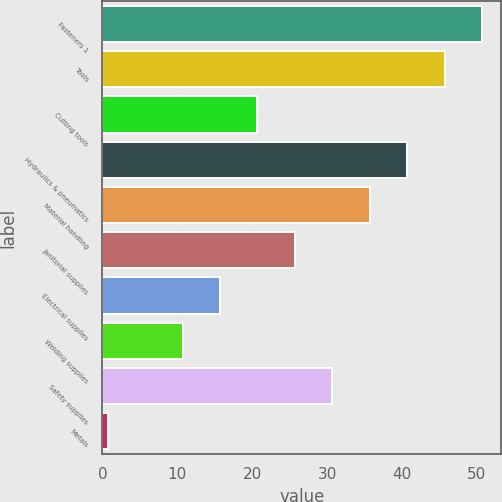<chart> <loc_0><loc_0><loc_500><loc_500><bar_chart><fcel>Fasteners 1<fcel>Tools<fcel>Cutting tools<fcel>Hydraulics & pneumatics<fcel>Material handling<fcel>Janitorial supplies<fcel>Electrical supplies<fcel>Welding supplies<fcel>Safety supplies<fcel>Metals<nl><fcel>50.7<fcel>45.7<fcel>20.7<fcel>40.7<fcel>35.7<fcel>25.7<fcel>15.7<fcel>10.7<fcel>30.7<fcel>0.7<nl></chart> 